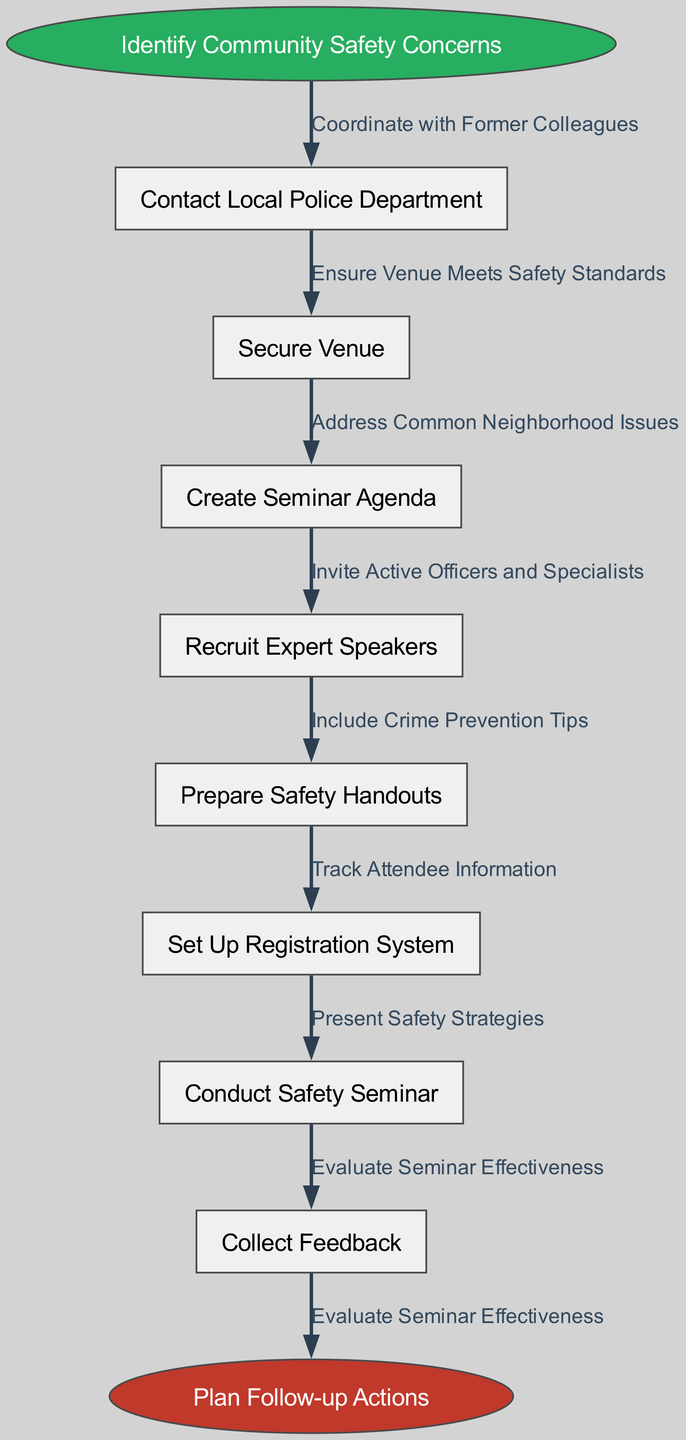What is the start node of the workflow? The start node is explicitly defined in the diagram as "Identify Community Safety Concerns."
Answer: Identify Community Safety Concerns How many nodes are there in total? The total number of nodes includes the start node, the intermediate nodes, and the end node. There are 1 start node + 7 intermediate nodes + 1 end node = 9 total nodes.
Answer: 9 What is the last node before the end node? The last node before the end node is "Collect Feedback," which is connected to the end node.
Answer: Collect Feedback Which node is linked to "Secure Venue"? The node linked to "Secure Venue" is "Create Seminar Agenda," as it follows in the flow after securing the venue.
Answer: Create Seminar Agenda What is the edge connecting the start node to the first intermediate node? The edge connecting the start node "Identify Community Safety Concerns" to the first intermediate node "Contact Local Police Department" is labeled "Coordinate with Former Colleagues."
Answer: Coordinate with Former Colleagues What are the first two steps in the workflow? The first two steps are "Identify Community Safety Concerns" and "Contact Local Police Department," showcasing the initial actions in the workflow sequence.
Answer: Identify Community Safety Concerns, Contact Local Police Department What role do the expert speakers play in the seminar preparation? The role of the expert speakers is indicated by the node "Recruit Expert Speakers," highlighting their importance in the seminar preparation process.
Answer: Recruit Expert Speakers Why is "Evaluate Seminar Effectiveness" important? "Evaluate Seminar Effectiveness" is crucial as the last action before planning follow-up actions, ensuring feedback is gathered to improve future seminars.
Answer: Evaluate Seminar Effectiveness Which node follows "Prepare Safety Handouts"? The node that follows "Prepare Safety Handouts" is "Set Up Registration System," demonstrating the next step in the workflow after preparing handouts.
Answer: Set Up Registration System How many edges connect the nodes? Each transition or connection between the nodes is represented as an edge. Counting all edges from the start to the end node reveals there are 8 edges connecting the nodes in total.
Answer: 8 